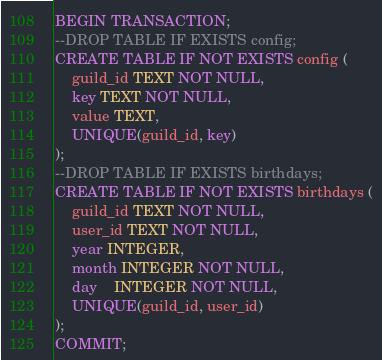Convert code to text. <code><loc_0><loc_0><loc_500><loc_500><_SQL_>BEGIN TRANSACTION;
--DROP TABLE IF EXISTS config;
CREATE TABLE IF NOT EXISTS config (
	guild_id TEXT NOT NULL,
	key TEXT NOT NULL,
	value TEXT,
	UNIQUE(guild_id, key)
);
--DROP TABLE IF EXISTS birthdays;
CREATE TABLE IF NOT EXISTS birthdays (
	guild_id TEXT NOT NULL,
	user_id TEXT NOT NULL,
	year INTEGER,
	month INTEGER NOT NULL,
	day	INTEGER NOT NULL,
	UNIQUE(guild_id, user_id)
);
COMMIT;
</code> 